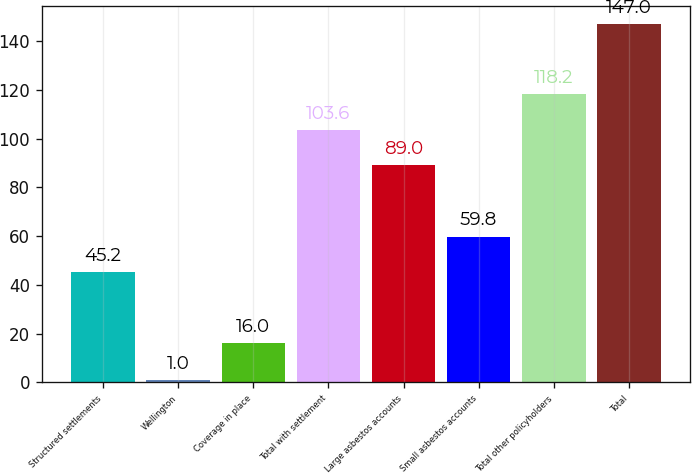Convert chart. <chart><loc_0><loc_0><loc_500><loc_500><bar_chart><fcel>Structured settlements<fcel>Wellington<fcel>Coverage in place<fcel>Total with settlement<fcel>Large asbestos accounts<fcel>Small asbestos accounts<fcel>Total other policyholders<fcel>Total<nl><fcel>45.2<fcel>1<fcel>16<fcel>103.6<fcel>89<fcel>59.8<fcel>118.2<fcel>147<nl></chart> 